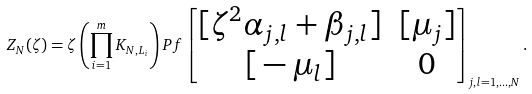Convert formula to latex. <formula><loc_0><loc_0><loc_500><loc_500>Z _ { N } ( \zeta ) = \zeta \left ( \prod _ { i = 1 } ^ { m } K _ { N , L _ { i } } \right ) P f \begin{bmatrix} { [ } \zeta ^ { 2 } \alpha _ { j , l } + \beta _ { j , l } ] & [ \mu _ { j } ] \\ { [ } - \mu _ { l } ] & 0 \end{bmatrix} _ { j , l = 1 , \dots , N } .</formula> 